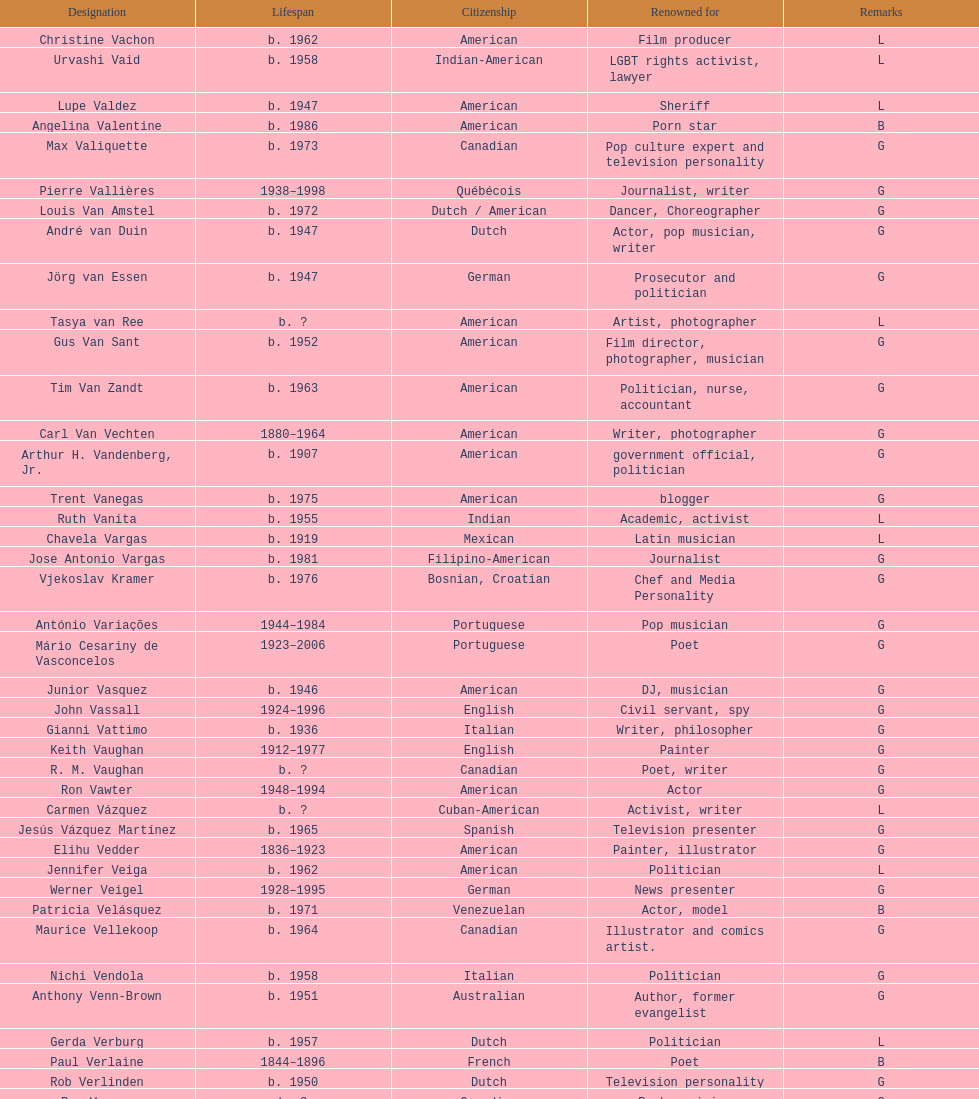Which nationality had the most notable poets? French. 